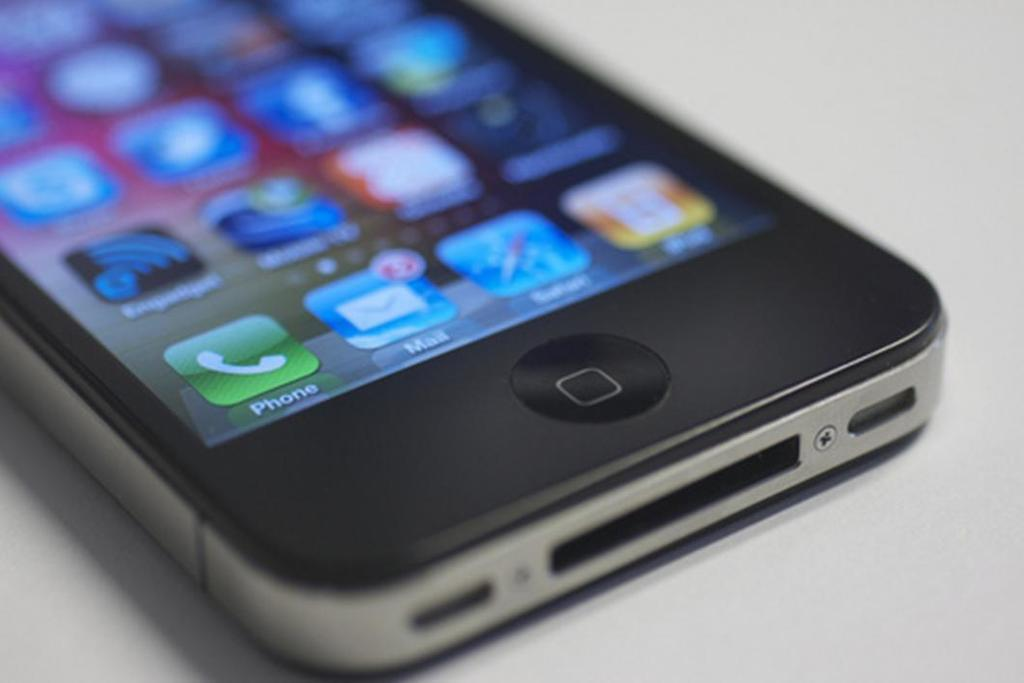<image>
Share a concise interpretation of the image provided. the name phone is on the phone that is a green icon 